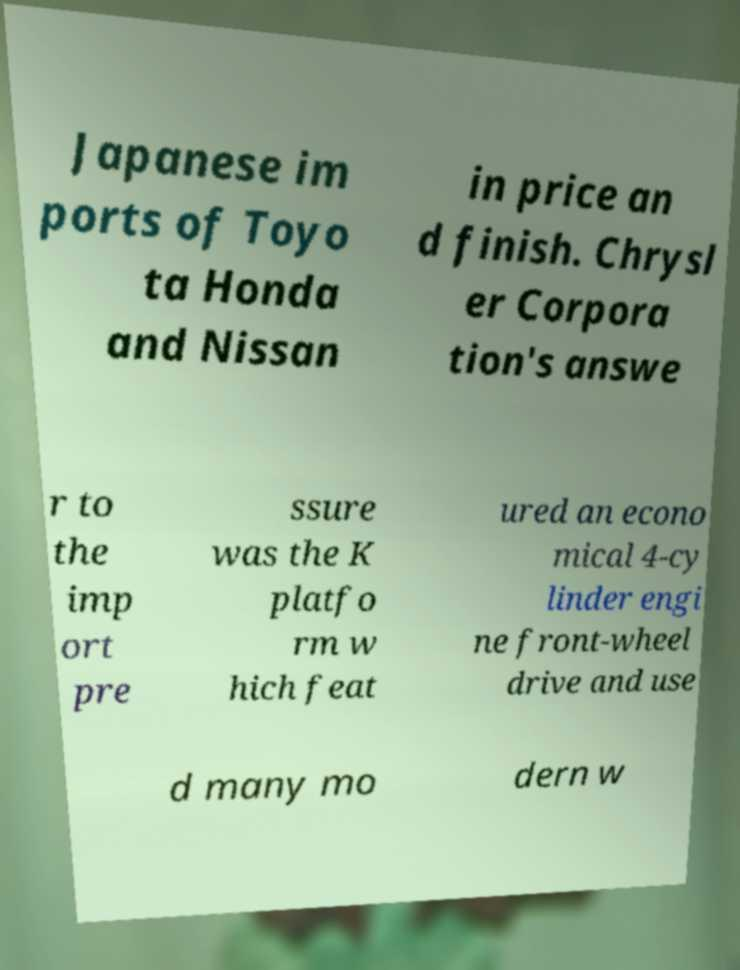For documentation purposes, I need the text within this image transcribed. Could you provide that? Japanese im ports of Toyo ta Honda and Nissan in price an d finish. Chrysl er Corpora tion's answe r to the imp ort pre ssure was the K platfo rm w hich feat ured an econo mical 4-cy linder engi ne front-wheel drive and use d many mo dern w 